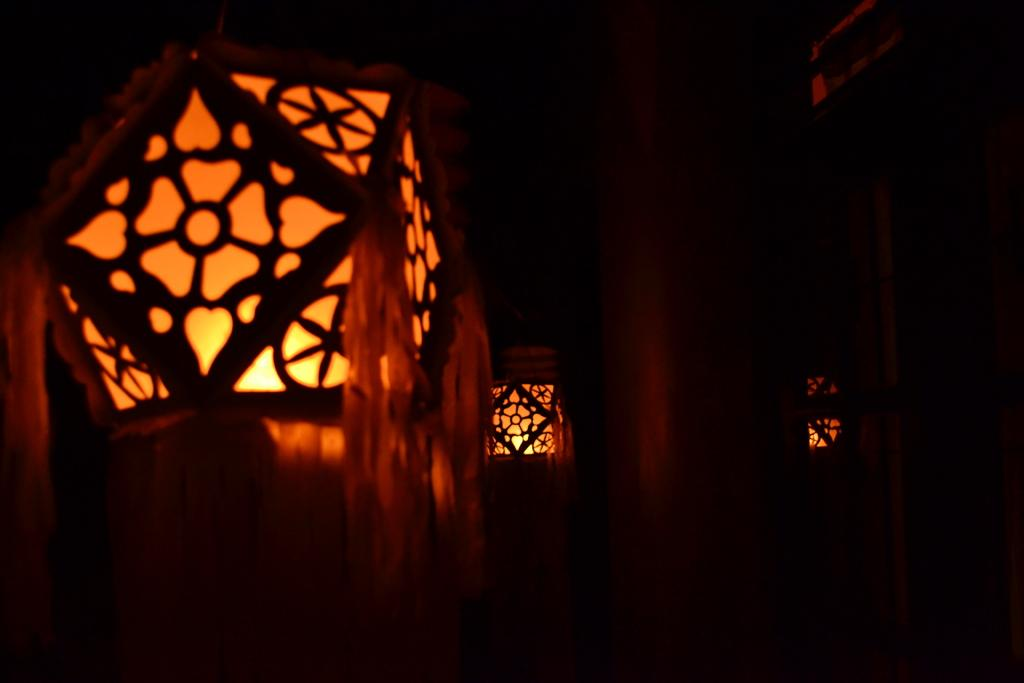What is the lighting condition in the room depicted in the image? The room in the image is dark. What type of waste is being disposed of in the image? There is no waste disposal visible in the image, as it only shows a dark room. How many roses can be seen on the dinner table in the image? There is no dinner table or roses present in the image; it only shows a dark room. 